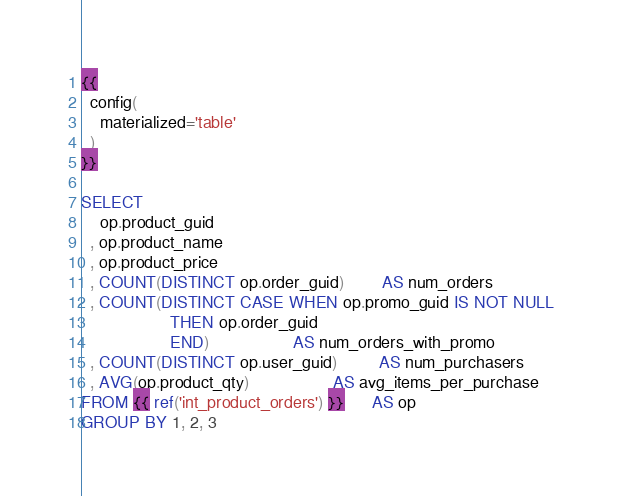<code> <loc_0><loc_0><loc_500><loc_500><_SQL_>{{
  config(
    materialized='table'
  )
}}

SELECT
    op.product_guid
  , op.product_name
  , op.product_price
  , COUNT(DISTINCT op.order_guid)        AS num_orders
  , COUNT(DISTINCT CASE WHEN op.promo_guid IS NOT NULL
                   THEN op.order_guid
                   END)                  AS num_orders_with_promo
  , COUNT(DISTINCT op.user_guid)         AS num_purchasers
  , AVG(op.product_qty)                  AS avg_items_per_purchase
FROM {{ ref('int_product_orders') }}      AS op
GROUP BY 1, 2, 3</code> 